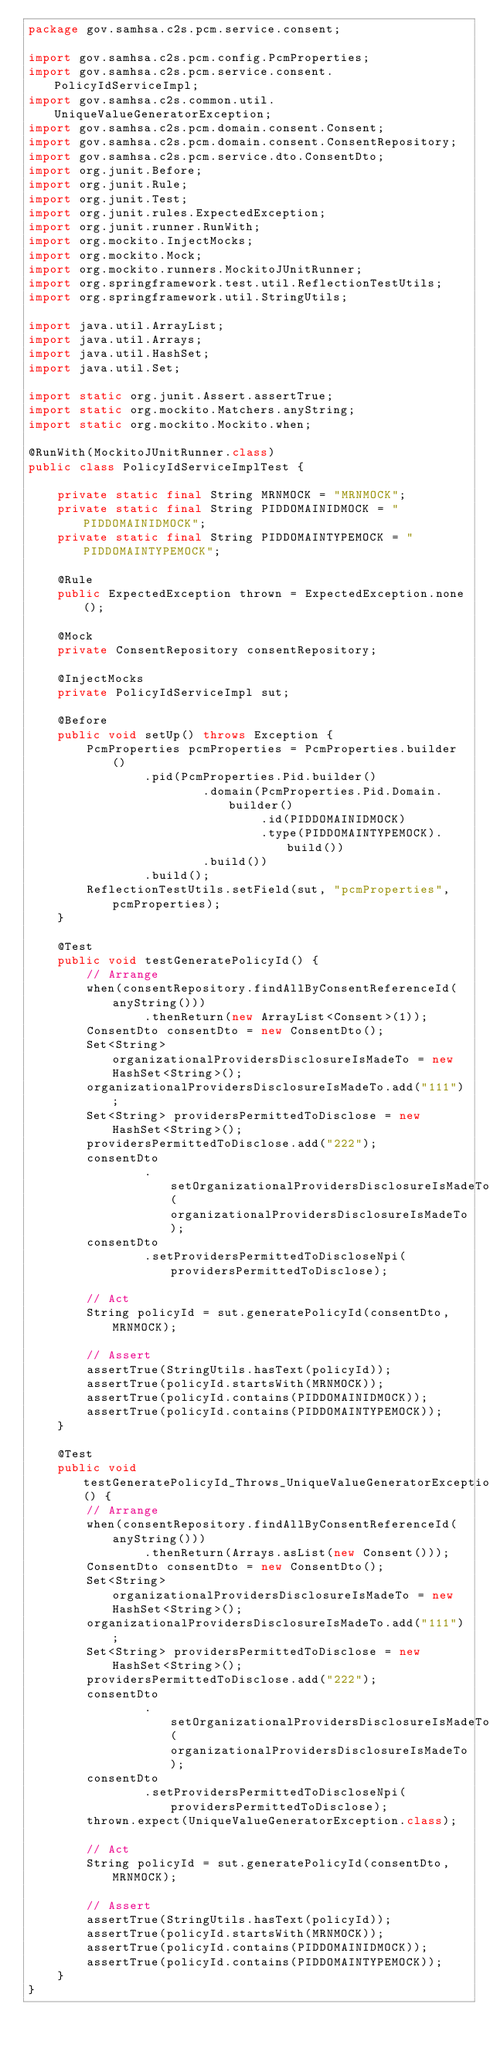<code> <loc_0><loc_0><loc_500><loc_500><_Java_>package gov.samhsa.c2s.pcm.service.consent;

import gov.samhsa.c2s.pcm.config.PcmProperties;
import gov.samhsa.c2s.pcm.service.consent.PolicyIdServiceImpl;
import gov.samhsa.c2s.common.util.UniqueValueGeneratorException;
import gov.samhsa.c2s.pcm.domain.consent.Consent;
import gov.samhsa.c2s.pcm.domain.consent.ConsentRepository;
import gov.samhsa.c2s.pcm.service.dto.ConsentDto;
import org.junit.Before;
import org.junit.Rule;
import org.junit.Test;
import org.junit.rules.ExpectedException;
import org.junit.runner.RunWith;
import org.mockito.InjectMocks;
import org.mockito.Mock;
import org.mockito.runners.MockitoJUnitRunner;
import org.springframework.test.util.ReflectionTestUtils;
import org.springframework.util.StringUtils;

import java.util.ArrayList;
import java.util.Arrays;
import java.util.HashSet;
import java.util.Set;

import static org.junit.Assert.assertTrue;
import static org.mockito.Matchers.anyString;
import static org.mockito.Mockito.when;

@RunWith(MockitoJUnitRunner.class)
public class PolicyIdServiceImplTest {

    private static final String MRNMOCK = "MRNMOCK";
    private static final String PIDDOMAINIDMOCK = "PIDDOMAINIDMOCK";
    private static final String PIDDOMAINTYPEMOCK = "PIDDOMAINTYPEMOCK";

    @Rule
    public ExpectedException thrown = ExpectedException.none();

    @Mock
    private ConsentRepository consentRepository;

    @InjectMocks
    private PolicyIdServiceImpl sut;

    @Before
    public void setUp() throws Exception {
        PcmProperties pcmProperties = PcmProperties.builder()
                .pid(PcmProperties.Pid.builder()
                        .domain(PcmProperties.Pid.Domain.builder()
                                .id(PIDDOMAINIDMOCK)
                                .type(PIDDOMAINTYPEMOCK).build())
                        .build())
                .build();
        ReflectionTestUtils.setField(sut, "pcmProperties", pcmProperties);
    }

    @Test
    public void testGeneratePolicyId() {
        // Arrange
        when(consentRepository.findAllByConsentReferenceId(anyString()))
                .thenReturn(new ArrayList<Consent>(1));
        ConsentDto consentDto = new ConsentDto();
        Set<String> organizationalProvidersDisclosureIsMadeTo = new HashSet<String>();
        organizationalProvidersDisclosureIsMadeTo.add("111");
        Set<String> providersPermittedToDisclose = new HashSet<String>();
        providersPermittedToDisclose.add("222");
        consentDto
                .setOrganizationalProvidersDisclosureIsMadeToNpi(organizationalProvidersDisclosureIsMadeTo);
        consentDto
                .setProvidersPermittedToDiscloseNpi(providersPermittedToDisclose);

        // Act
        String policyId = sut.generatePolicyId(consentDto, MRNMOCK);

        // Assert
        assertTrue(StringUtils.hasText(policyId));
        assertTrue(policyId.startsWith(MRNMOCK));
        assertTrue(policyId.contains(PIDDOMAINIDMOCK));
        assertTrue(policyId.contains(PIDDOMAINTYPEMOCK));
    }

    @Test
    public void testGeneratePolicyId_Throws_UniqueValueGeneratorException() {
        // Arrange
        when(consentRepository.findAllByConsentReferenceId(anyString()))
                .thenReturn(Arrays.asList(new Consent()));
        ConsentDto consentDto = new ConsentDto();
        Set<String> organizationalProvidersDisclosureIsMadeTo = new HashSet<String>();
        organizationalProvidersDisclosureIsMadeTo.add("111");
        Set<String> providersPermittedToDisclose = new HashSet<String>();
        providersPermittedToDisclose.add("222");
        consentDto
                .setOrganizationalProvidersDisclosureIsMadeToNpi(organizationalProvidersDisclosureIsMadeTo);
        consentDto
                .setProvidersPermittedToDiscloseNpi(providersPermittedToDisclose);
        thrown.expect(UniqueValueGeneratorException.class);

        // Act
        String policyId = sut.generatePolicyId(consentDto, MRNMOCK);

        // Assert
        assertTrue(StringUtils.hasText(policyId));
        assertTrue(policyId.startsWith(MRNMOCK));
        assertTrue(policyId.contains(PIDDOMAINIDMOCK));
        assertTrue(policyId.contains(PIDDOMAINTYPEMOCK));
    }
}
</code> 